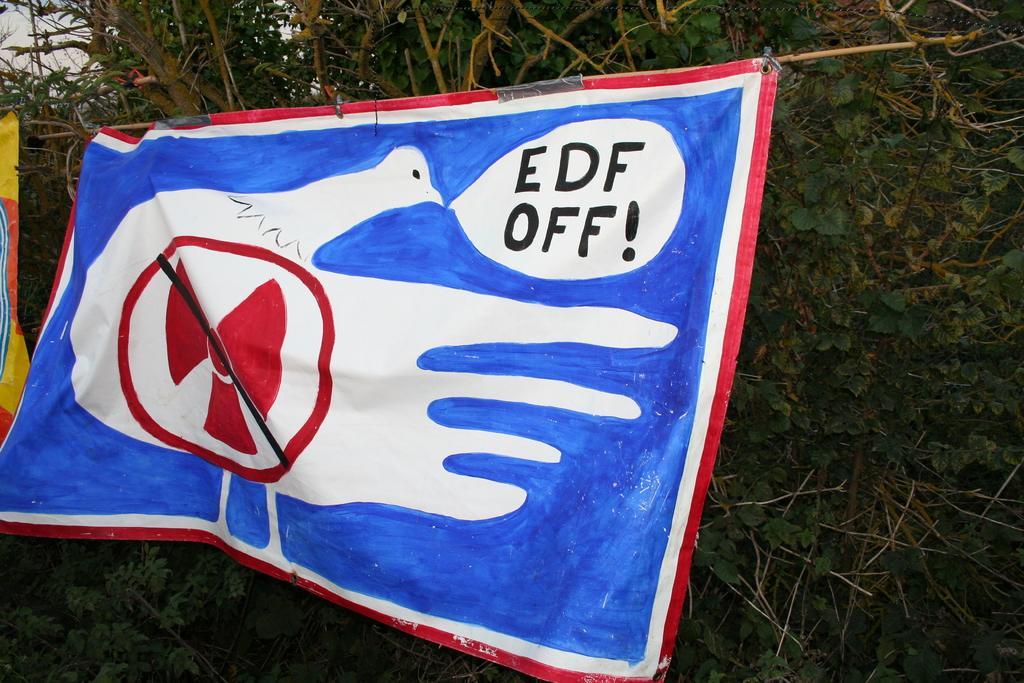Describe this image in one or two sentences. In this picture we can see few flags and trees. 